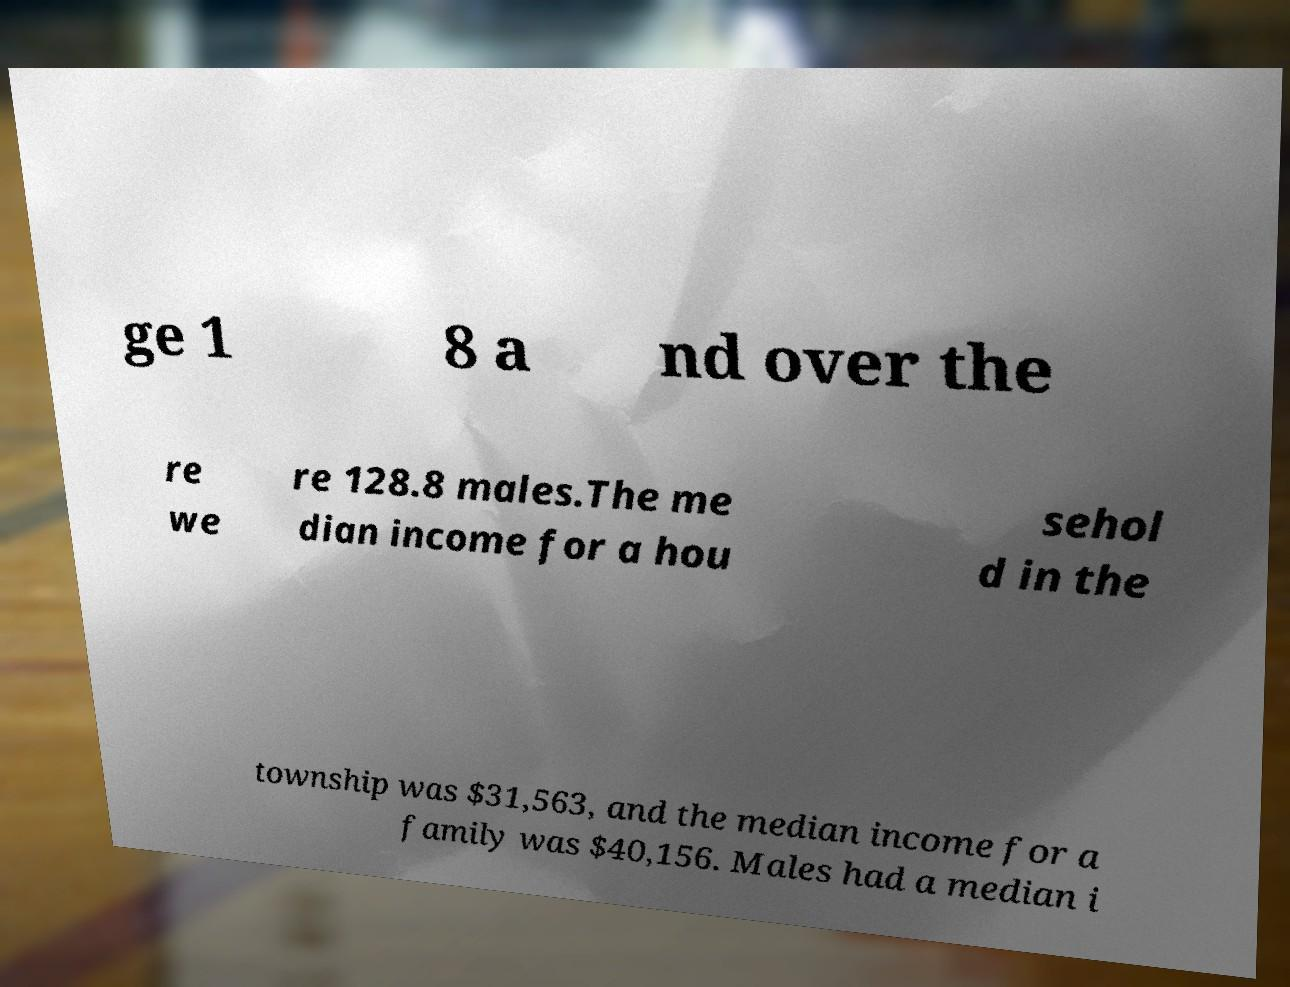For documentation purposes, I need the text within this image transcribed. Could you provide that? ge 1 8 a nd over the re we re 128.8 males.The me dian income for a hou sehol d in the township was $31,563, and the median income for a family was $40,156. Males had a median i 